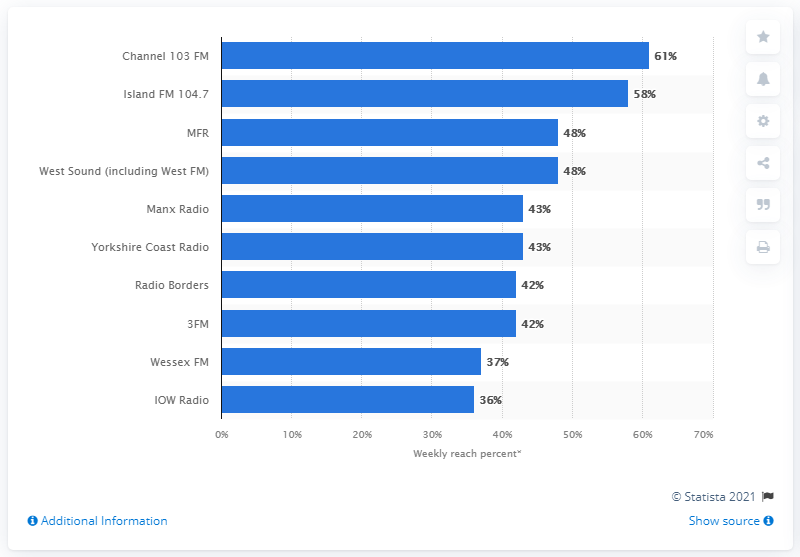Outline some significant characteristics in this image. According to data from the first quarter of 2020, Channel 103 FM had the highest reach percentage among all radio stations. 